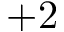<formula> <loc_0><loc_0><loc_500><loc_500>+ 2</formula> 